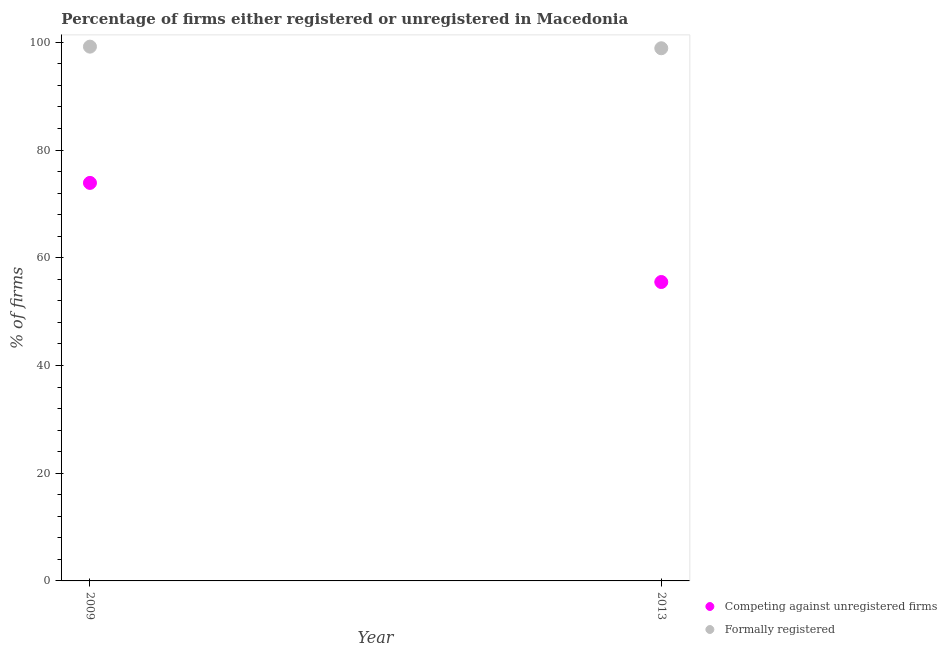What is the percentage of formally registered firms in 2013?
Your answer should be very brief. 98.9. Across all years, what is the maximum percentage of formally registered firms?
Your answer should be very brief. 99.2. Across all years, what is the minimum percentage of formally registered firms?
Give a very brief answer. 98.9. In which year was the percentage of registered firms maximum?
Your response must be concise. 2009. In which year was the percentage of registered firms minimum?
Give a very brief answer. 2013. What is the total percentage of registered firms in the graph?
Your response must be concise. 129.4. What is the difference between the percentage of registered firms in 2009 and that in 2013?
Give a very brief answer. 18.4. What is the difference between the percentage of formally registered firms in 2013 and the percentage of registered firms in 2009?
Provide a short and direct response. 25. What is the average percentage of registered firms per year?
Give a very brief answer. 64.7. In the year 2009, what is the difference between the percentage of formally registered firms and percentage of registered firms?
Make the answer very short. 25.3. In how many years, is the percentage of registered firms greater than 96 %?
Your answer should be very brief. 0. What is the ratio of the percentage of registered firms in 2009 to that in 2013?
Ensure brevity in your answer.  1.33. Does the graph contain grids?
Your response must be concise. No. What is the title of the graph?
Keep it short and to the point. Percentage of firms either registered or unregistered in Macedonia. What is the label or title of the Y-axis?
Offer a very short reply. % of firms. What is the % of firms of Competing against unregistered firms in 2009?
Ensure brevity in your answer.  73.9. What is the % of firms in Formally registered in 2009?
Your answer should be very brief. 99.2. What is the % of firms of Competing against unregistered firms in 2013?
Offer a terse response. 55.5. What is the % of firms of Formally registered in 2013?
Provide a succinct answer. 98.9. Across all years, what is the maximum % of firms in Competing against unregistered firms?
Provide a succinct answer. 73.9. Across all years, what is the maximum % of firms of Formally registered?
Keep it short and to the point. 99.2. Across all years, what is the minimum % of firms in Competing against unregistered firms?
Your response must be concise. 55.5. Across all years, what is the minimum % of firms in Formally registered?
Offer a very short reply. 98.9. What is the total % of firms of Competing against unregistered firms in the graph?
Provide a succinct answer. 129.4. What is the total % of firms of Formally registered in the graph?
Provide a short and direct response. 198.1. What is the difference between the % of firms in Competing against unregistered firms in 2009 and that in 2013?
Keep it short and to the point. 18.4. What is the average % of firms of Competing against unregistered firms per year?
Make the answer very short. 64.7. What is the average % of firms of Formally registered per year?
Offer a terse response. 99.05. In the year 2009, what is the difference between the % of firms in Competing against unregistered firms and % of firms in Formally registered?
Offer a terse response. -25.3. In the year 2013, what is the difference between the % of firms in Competing against unregistered firms and % of firms in Formally registered?
Your answer should be compact. -43.4. What is the ratio of the % of firms in Competing against unregistered firms in 2009 to that in 2013?
Your answer should be compact. 1.33. What is the difference between the highest and the second highest % of firms of Competing against unregistered firms?
Make the answer very short. 18.4. What is the difference between the highest and the lowest % of firms in Competing against unregistered firms?
Give a very brief answer. 18.4. What is the difference between the highest and the lowest % of firms in Formally registered?
Ensure brevity in your answer.  0.3. 